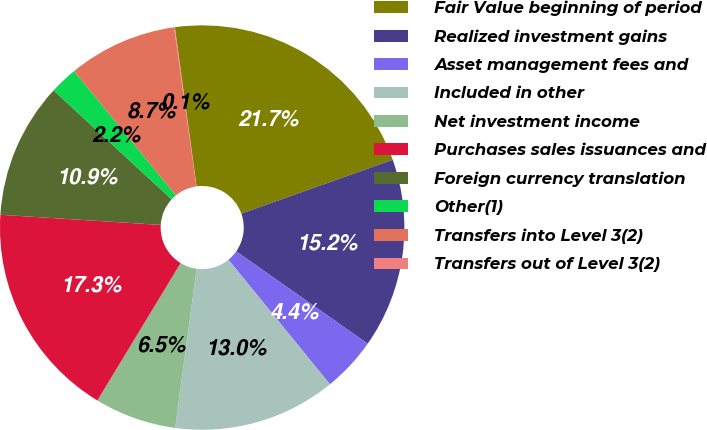Convert chart to OTSL. <chart><loc_0><loc_0><loc_500><loc_500><pie_chart><fcel>Fair Value beginning of period<fcel>Realized investment gains<fcel>Asset management fees and<fcel>Included in other<fcel>Net investment income<fcel>Purchases sales issuances and<fcel>Foreign currency translation<fcel>Other(1)<fcel>Transfers into Level 3(2)<fcel>Transfers out of Level 3(2)<nl><fcel>21.73%<fcel>15.18%<fcel>4.38%<fcel>13.02%<fcel>6.54%<fcel>17.34%<fcel>10.86%<fcel>2.22%<fcel>8.7%<fcel>0.06%<nl></chart> 